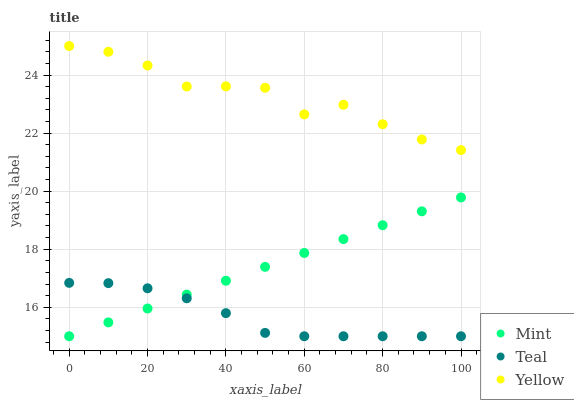Does Teal have the minimum area under the curve?
Answer yes or no. Yes. Does Yellow have the maximum area under the curve?
Answer yes or no. Yes. Does Yellow have the minimum area under the curve?
Answer yes or no. No. Does Teal have the maximum area under the curve?
Answer yes or no. No. Is Mint the smoothest?
Answer yes or no. Yes. Is Yellow the roughest?
Answer yes or no. Yes. Is Teal the smoothest?
Answer yes or no. No. Is Teal the roughest?
Answer yes or no. No. Does Mint have the lowest value?
Answer yes or no. Yes. Does Yellow have the lowest value?
Answer yes or no. No. Does Yellow have the highest value?
Answer yes or no. Yes. Does Teal have the highest value?
Answer yes or no. No. Is Mint less than Yellow?
Answer yes or no. Yes. Is Yellow greater than Mint?
Answer yes or no. Yes. Does Mint intersect Teal?
Answer yes or no. Yes. Is Mint less than Teal?
Answer yes or no. No. Is Mint greater than Teal?
Answer yes or no. No. Does Mint intersect Yellow?
Answer yes or no. No. 